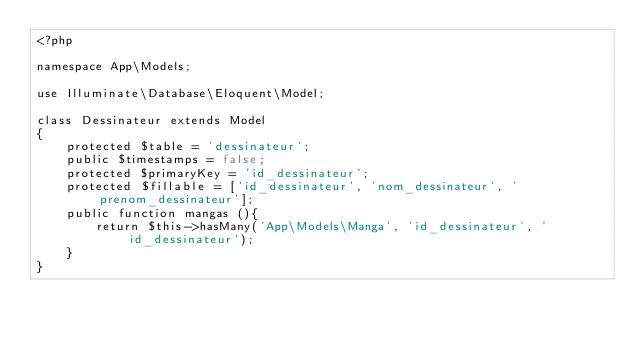<code> <loc_0><loc_0><loc_500><loc_500><_PHP_><?php

namespace App\Models;

use Illuminate\Database\Eloquent\Model;

class Dessinateur extends Model
{
    protected $table = 'dessinateur';
    public $timestamps = false;
    protected $primaryKey = 'id_dessinateur';
    protected $fillable = ['id_dessinateur', 'nom_dessinateur', 'prenom_dessinateur'];
    public function mangas (){
        return $this->hasMany('App\Models\Manga', 'id_dessinateur', 'id_dessinateur');
    }    
}
</code> 